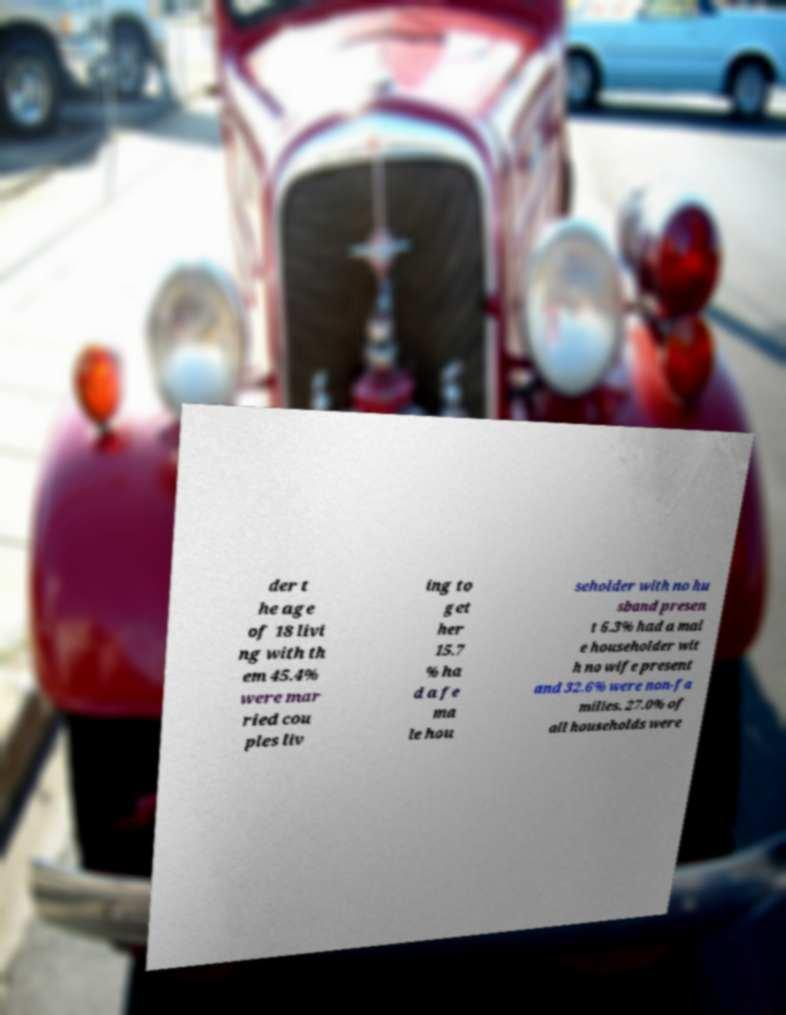Could you extract and type out the text from this image? der t he age of 18 livi ng with th em 45.4% were mar ried cou ples liv ing to get her 15.7 % ha d a fe ma le hou seholder with no hu sband presen t 6.3% had a mal e householder wit h no wife present and 32.6% were non-fa milies. 27.0% of all households were 